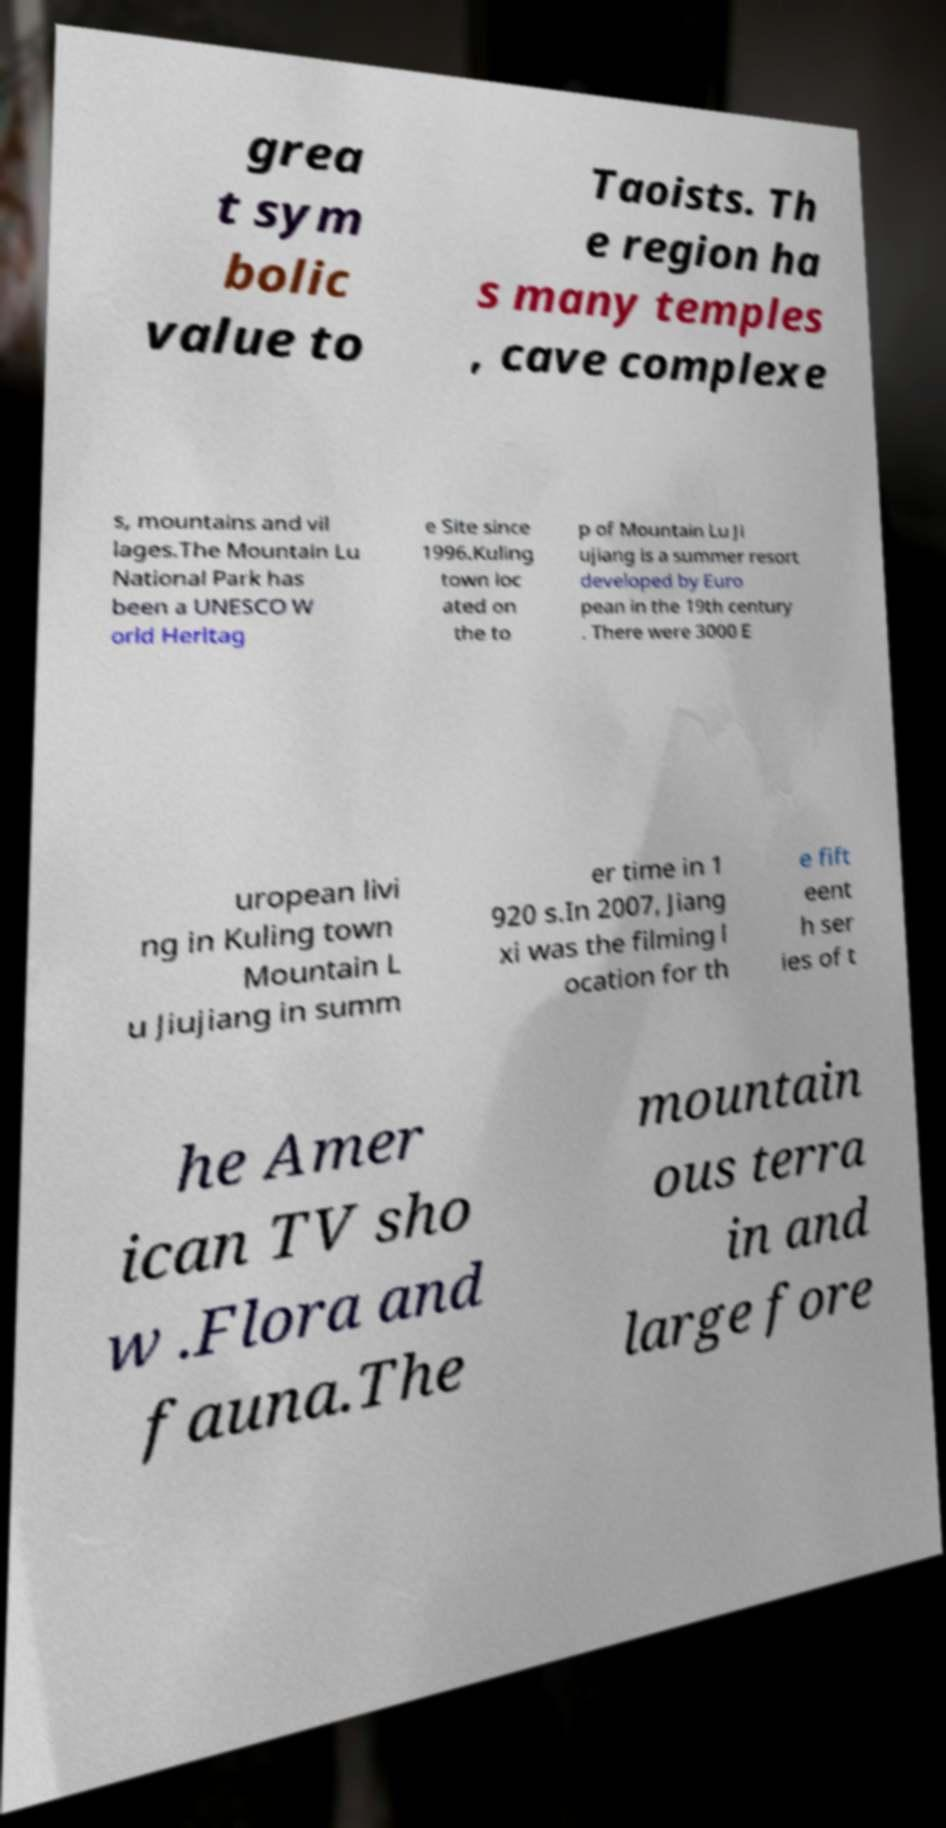Please identify and transcribe the text found in this image. grea t sym bolic value to Taoists. Th e region ha s many temples , cave complexe s, mountains and vil lages.The Mountain Lu National Park has been a UNESCO W orld Heritag e Site since 1996.Kuling town loc ated on the to p of Mountain Lu Ji ujiang is a summer resort developed by Euro pean in the 19th century . There were 3000 E uropean livi ng in Kuling town Mountain L u Jiujiang in summ er time in 1 920 s.In 2007, Jiang xi was the filming l ocation for th e fift eent h ser ies of t he Amer ican TV sho w .Flora and fauna.The mountain ous terra in and large fore 